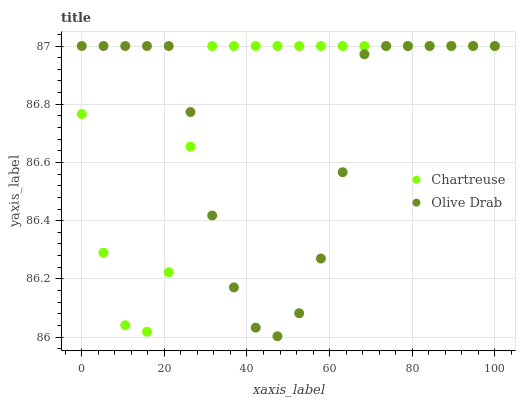Does Olive Drab have the minimum area under the curve?
Answer yes or no. Yes. Does Chartreuse have the maximum area under the curve?
Answer yes or no. Yes. Does Olive Drab have the maximum area under the curve?
Answer yes or no. No. Is Chartreuse the smoothest?
Answer yes or no. Yes. Is Olive Drab the roughest?
Answer yes or no. Yes. Is Olive Drab the smoothest?
Answer yes or no. No. Does Olive Drab have the lowest value?
Answer yes or no. Yes. Does Olive Drab have the highest value?
Answer yes or no. Yes. Does Olive Drab intersect Chartreuse?
Answer yes or no. Yes. Is Olive Drab less than Chartreuse?
Answer yes or no. No. Is Olive Drab greater than Chartreuse?
Answer yes or no. No. 